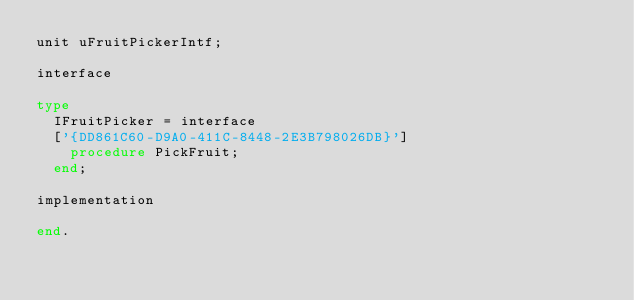Convert code to text. <code><loc_0><loc_0><loc_500><loc_500><_Pascal_>unit uFruitPickerIntf;

interface

type
  IFruitPicker = interface
  ['{DD861C60-D9A0-411C-8448-2E3B798026DB}']
    procedure PickFruit;
  end;

implementation

end.
</code> 